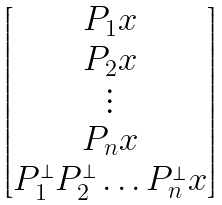Convert formula to latex. <formula><loc_0><loc_0><loc_500><loc_500>\begin{bmatrix} P _ { 1 } x \\ P _ { 2 } x \\ \vdots \\ P _ { n } x \\ P _ { 1 } ^ { \perp } P _ { 2 } ^ { \perp } \dots P _ { n } ^ { \perp } x \end{bmatrix}</formula> 